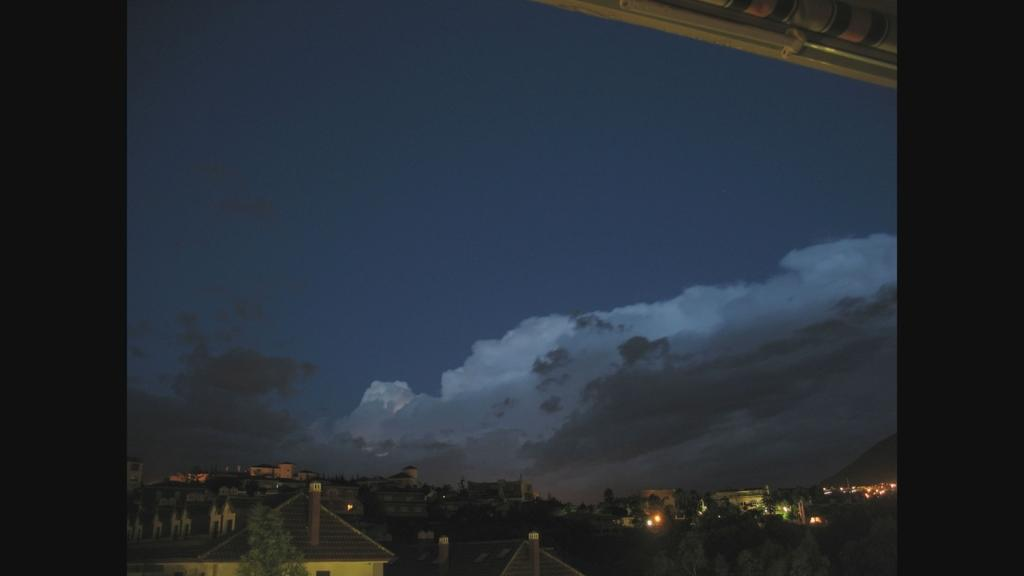What type of structures can be seen in the image? There are houses in the image. What else is visible besides the houses? There are lights and trees visible in the image. What can be seen in the sky in the image? The sky is visible in the image, and clouds are present. What type of music is the band playing in the image? A: There is no band present in the image. What does the robin desire in the image? There is no robin present in the image. 